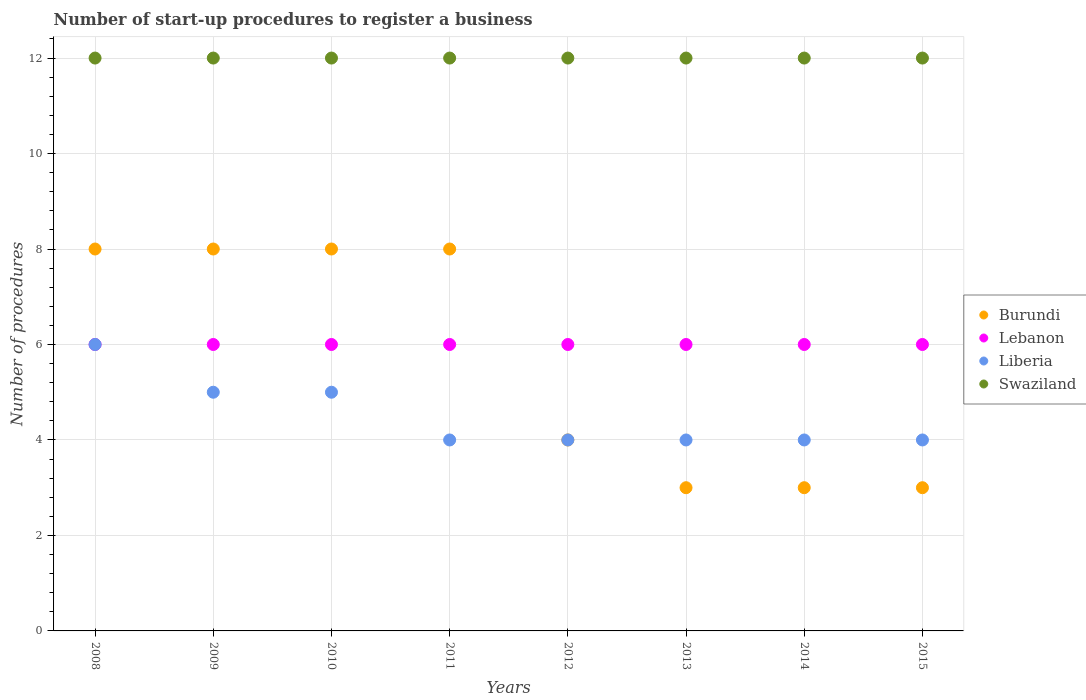What is the number of procedures required to register a business in Liberia in 2014?
Give a very brief answer. 4. Across all years, what is the maximum number of procedures required to register a business in Burundi?
Provide a succinct answer. 8. In which year was the number of procedures required to register a business in Lebanon minimum?
Make the answer very short. 2008. What is the total number of procedures required to register a business in Burundi in the graph?
Provide a short and direct response. 45. What is the difference between the number of procedures required to register a business in Lebanon in 2008 and that in 2009?
Provide a succinct answer. 0. What is the average number of procedures required to register a business in Lebanon per year?
Give a very brief answer. 6. In the year 2013, what is the difference between the number of procedures required to register a business in Liberia and number of procedures required to register a business in Burundi?
Your response must be concise. 1. What is the ratio of the number of procedures required to register a business in Liberia in 2009 to that in 2014?
Provide a short and direct response. 1.25. Is the number of procedures required to register a business in Burundi in 2011 less than that in 2014?
Your answer should be compact. No. Is the difference between the number of procedures required to register a business in Liberia in 2009 and 2011 greater than the difference between the number of procedures required to register a business in Burundi in 2009 and 2011?
Offer a very short reply. Yes. What is the difference between the highest and the lowest number of procedures required to register a business in Burundi?
Give a very brief answer. 5. Is the sum of the number of procedures required to register a business in Swaziland in 2011 and 2015 greater than the maximum number of procedures required to register a business in Burundi across all years?
Provide a short and direct response. Yes. Is it the case that in every year, the sum of the number of procedures required to register a business in Swaziland and number of procedures required to register a business in Burundi  is greater than the number of procedures required to register a business in Liberia?
Offer a very short reply. Yes. Does the number of procedures required to register a business in Burundi monotonically increase over the years?
Offer a very short reply. No. Is the number of procedures required to register a business in Liberia strictly greater than the number of procedures required to register a business in Swaziland over the years?
Provide a succinct answer. No. Is the number of procedures required to register a business in Burundi strictly less than the number of procedures required to register a business in Swaziland over the years?
Offer a very short reply. Yes. How many dotlines are there?
Keep it short and to the point. 4. How many years are there in the graph?
Your response must be concise. 8. What is the difference between two consecutive major ticks on the Y-axis?
Keep it short and to the point. 2. Does the graph contain any zero values?
Offer a very short reply. No. Does the graph contain grids?
Offer a very short reply. Yes. Where does the legend appear in the graph?
Offer a very short reply. Center right. How are the legend labels stacked?
Keep it short and to the point. Vertical. What is the title of the graph?
Your answer should be very brief. Number of start-up procedures to register a business. What is the label or title of the X-axis?
Give a very brief answer. Years. What is the label or title of the Y-axis?
Make the answer very short. Number of procedures. What is the Number of procedures of Burundi in 2008?
Offer a very short reply. 8. What is the Number of procedures of Swaziland in 2008?
Keep it short and to the point. 12. What is the Number of procedures in Burundi in 2009?
Offer a very short reply. 8. What is the Number of procedures of Lebanon in 2009?
Provide a succinct answer. 6. What is the Number of procedures in Liberia in 2009?
Your answer should be very brief. 5. What is the Number of procedures in Burundi in 2010?
Your answer should be very brief. 8. What is the Number of procedures of Liberia in 2010?
Give a very brief answer. 5. What is the Number of procedures in Burundi in 2011?
Offer a terse response. 8. What is the Number of procedures of Lebanon in 2011?
Keep it short and to the point. 6. What is the Number of procedures of Swaziland in 2011?
Your response must be concise. 12. What is the Number of procedures of Burundi in 2012?
Provide a succinct answer. 4. What is the Number of procedures of Burundi in 2013?
Ensure brevity in your answer.  3. What is the Number of procedures of Swaziland in 2013?
Keep it short and to the point. 12. What is the Number of procedures in Liberia in 2014?
Offer a terse response. 4. What is the Number of procedures of Swaziland in 2014?
Provide a short and direct response. 12. What is the Number of procedures of Burundi in 2015?
Keep it short and to the point. 3. What is the Number of procedures of Liberia in 2015?
Make the answer very short. 4. What is the Number of procedures in Swaziland in 2015?
Your answer should be very brief. 12. Across all years, what is the maximum Number of procedures in Burundi?
Offer a very short reply. 8. Across all years, what is the maximum Number of procedures of Liberia?
Provide a succinct answer. 6. Across all years, what is the minimum Number of procedures of Burundi?
Provide a succinct answer. 3. Across all years, what is the minimum Number of procedures of Lebanon?
Your response must be concise. 6. Across all years, what is the minimum Number of procedures in Liberia?
Keep it short and to the point. 4. What is the total Number of procedures in Burundi in the graph?
Provide a short and direct response. 45. What is the total Number of procedures of Swaziland in the graph?
Your response must be concise. 96. What is the difference between the Number of procedures of Burundi in 2008 and that in 2009?
Offer a very short reply. 0. What is the difference between the Number of procedures of Liberia in 2008 and that in 2009?
Provide a succinct answer. 1. What is the difference between the Number of procedures in Swaziland in 2008 and that in 2009?
Make the answer very short. 0. What is the difference between the Number of procedures of Swaziland in 2008 and that in 2010?
Make the answer very short. 0. What is the difference between the Number of procedures in Burundi in 2008 and that in 2011?
Offer a terse response. 0. What is the difference between the Number of procedures in Lebanon in 2008 and that in 2011?
Give a very brief answer. 0. What is the difference between the Number of procedures in Burundi in 2008 and that in 2012?
Give a very brief answer. 4. What is the difference between the Number of procedures in Swaziland in 2008 and that in 2012?
Ensure brevity in your answer.  0. What is the difference between the Number of procedures of Liberia in 2008 and that in 2013?
Ensure brevity in your answer.  2. What is the difference between the Number of procedures of Burundi in 2008 and that in 2014?
Your answer should be compact. 5. What is the difference between the Number of procedures in Lebanon in 2008 and that in 2014?
Offer a terse response. 0. What is the difference between the Number of procedures in Liberia in 2008 and that in 2014?
Provide a short and direct response. 2. What is the difference between the Number of procedures of Lebanon in 2009 and that in 2010?
Make the answer very short. 0. What is the difference between the Number of procedures of Liberia in 2009 and that in 2010?
Provide a succinct answer. 0. What is the difference between the Number of procedures in Lebanon in 2009 and that in 2011?
Ensure brevity in your answer.  0. What is the difference between the Number of procedures of Swaziland in 2009 and that in 2011?
Your answer should be compact. 0. What is the difference between the Number of procedures of Burundi in 2009 and that in 2012?
Offer a very short reply. 4. What is the difference between the Number of procedures in Lebanon in 2009 and that in 2012?
Offer a very short reply. 0. What is the difference between the Number of procedures of Liberia in 2009 and that in 2012?
Provide a succinct answer. 1. What is the difference between the Number of procedures of Swaziland in 2009 and that in 2012?
Give a very brief answer. 0. What is the difference between the Number of procedures in Liberia in 2009 and that in 2013?
Offer a very short reply. 1. What is the difference between the Number of procedures of Lebanon in 2009 and that in 2015?
Offer a terse response. 0. What is the difference between the Number of procedures of Liberia in 2009 and that in 2015?
Give a very brief answer. 1. What is the difference between the Number of procedures in Swaziland in 2009 and that in 2015?
Make the answer very short. 0. What is the difference between the Number of procedures in Liberia in 2010 and that in 2011?
Your answer should be very brief. 1. What is the difference between the Number of procedures of Burundi in 2010 and that in 2012?
Keep it short and to the point. 4. What is the difference between the Number of procedures in Liberia in 2010 and that in 2012?
Make the answer very short. 1. What is the difference between the Number of procedures in Swaziland in 2010 and that in 2012?
Ensure brevity in your answer.  0. What is the difference between the Number of procedures of Lebanon in 2010 and that in 2013?
Offer a very short reply. 0. What is the difference between the Number of procedures in Liberia in 2010 and that in 2013?
Your response must be concise. 1. What is the difference between the Number of procedures in Burundi in 2010 and that in 2014?
Ensure brevity in your answer.  5. What is the difference between the Number of procedures in Lebanon in 2010 and that in 2014?
Offer a terse response. 0. What is the difference between the Number of procedures in Lebanon in 2010 and that in 2015?
Provide a succinct answer. 0. What is the difference between the Number of procedures in Swaziland in 2010 and that in 2015?
Make the answer very short. 0. What is the difference between the Number of procedures in Burundi in 2011 and that in 2012?
Your response must be concise. 4. What is the difference between the Number of procedures in Lebanon in 2011 and that in 2013?
Provide a succinct answer. 0. What is the difference between the Number of procedures in Liberia in 2011 and that in 2013?
Provide a short and direct response. 0. What is the difference between the Number of procedures in Burundi in 2011 and that in 2014?
Make the answer very short. 5. What is the difference between the Number of procedures in Lebanon in 2011 and that in 2015?
Provide a short and direct response. 0. What is the difference between the Number of procedures of Swaziland in 2011 and that in 2015?
Your answer should be very brief. 0. What is the difference between the Number of procedures of Burundi in 2012 and that in 2013?
Provide a succinct answer. 1. What is the difference between the Number of procedures of Swaziland in 2012 and that in 2013?
Offer a very short reply. 0. What is the difference between the Number of procedures in Lebanon in 2012 and that in 2014?
Make the answer very short. 0. What is the difference between the Number of procedures of Burundi in 2012 and that in 2015?
Provide a succinct answer. 1. What is the difference between the Number of procedures of Lebanon in 2012 and that in 2015?
Provide a short and direct response. 0. What is the difference between the Number of procedures of Swaziland in 2012 and that in 2015?
Your answer should be very brief. 0. What is the difference between the Number of procedures of Liberia in 2013 and that in 2014?
Provide a short and direct response. 0. What is the difference between the Number of procedures of Swaziland in 2013 and that in 2014?
Provide a succinct answer. 0. What is the difference between the Number of procedures in Burundi in 2013 and that in 2015?
Keep it short and to the point. 0. What is the difference between the Number of procedures of Lebanon in 2013 and that in 2015?
Your answer should be very brief. 0. What is the difference between the Number of procedures of Swaziland in 2013 and that in 2015?
Provide a succinct answer. 0. What is the difference between the Number of procedures in Burundi in 2014 and that in 2015?
Offer a very short reply. 0. What is the difference between the Number of procedures in Lebanon in 2014 and that in 2015?
Ensure brevity in your answer.  0. What is the difference between the Number of procedures in Burundi in 2008 and the Number of procedures in Lebanon in 2010?
Your answer should be compact. 2. What is the difference between the Number of procedures in Burundi in 2008 and the Number of procedures in Liberia in 2010?
Provide a short and direct response. 3. What is the difference between the Number of procedures in Burundi in 2008 and the Number of procedures in Swaziland in 2010?
Give a very brief answer. -4. What is the difference between the Number of procedures in Lebanon in 2008 and the Number of procedures in Liberia in 2010?
Offer a very short reply. 1. What is the difference between the Number of procedures in Burundi in 2008 and the Number of procedures in Lebanon in 2011?
Offer a terse response. 2. What is the difference between the Number of procedures of Burundi in 2008 and the Number of procedures of Liberia in 2011?
Provide a succinct answer. 4. What is the difference between the Number of procedures in Lebanon in 2008 and the Number of procedures in Liberia in 2011?
Provide a succinct answer. 2. What is the difference between the Number of procedures of Liberia in 2008 and the Number of procedures of Swaziland in 2011?
Keep it short and to the point. -6. What is the difference between the Number of procedures in Burundi in 2008 and the Number of procedures in Liberia in 2012?
Give a very brief answer. 4. What is the difference between the Number of procedures of Lebanon in 2008 and the Number of procedures of Swaziland in 2012?
Your answer should be compact. -6. What is the difference between the Number of procedures of Liberia in 2008 and the Number of procedures of Swaziland in 2012?
Give a very brief answer. -6. What is the difference between the Number of procedures in Burundi in 2008 and the Number of procedures in Lebanon in 2013?
Your response must be concise. 2. What is the difference between the Number of procedures in Lebanon in 2008 and the Number of procedures in Liberia in 2013?
Give a very brief answer. 2. What is the difference between the Number of procedures in Burundi in 2008 and the Number of procedures in Liberia in 2014?
Keep it short and to the point. 4. What is the difference between the Number of procedures in Lebanon in 2008 and the Number of procedures in Swaziland in 2014?
Offer a terse response. -6. What is the difference between the Number of procedures of Burundi in 2008 and the Number of procedures of Swaziland in 2015?
Your answer should be very brief. -4. What is the difference between the Number of procedures of Lebanon in 2008 and the Number of procedures of Liberia in 2015?
Your answer should be compact. 2. What is the difference between the Number of procedures in Lebanon in 2008 and the Number of procedures in Swaziland in 2015?
Provide a succinct answer. -6. What is the difference between the Number of procedures in Burundi in 2009 and the Number of procedures in Lebanon in 2010?
Make the answer very short. 2. What is the difference between the Number of procedures in Lebanon in 2009 and the Number of procedures in Swaziland in 2010?
Keep it short and to the point. -6. What is the difference between the Number of procedures of Burundi in 2009 and the Number of procedures of Lebanon in 2011?
Your answer should be compact. 2. What is the difference between the Number of procedures of Burundi in 2009 and the Number of procedures of Liberia in 2011?
Your answer should be compact. 4. What is the difference between the Number of procedures in Lebanon in 2009 and the Number of procedures in Liberia in 2011?
Ensure brevity in your answer.  2. What is the difference between the Number of procedures in Liberia in 2009 and the Number of procedures in Swaziland in 2011?
Ensure brevity in your answer.  -7. What is the difference between the Number of procedures of Burundi in 2009 and the Number of procedures of Lebanon in 2012?
Your answer should be compact. 2. What is the difference between the Number of procedures of Burundi in 2009 and the Number of procedures of Liberia in 2012?
Your answer should be very brief. 4. What is the difference between the Number of procedures of Burundi in 2009 and the Number of procedures of Swaziland in 2012?
Provide a short and direct response. -4. What is the difference between the Number of procedures of Lebanon in 2009 and the Number of procedures of Liberia in 2012?
Make the answer very short. 2. What is the difference between the Number of procedures in Liberia in 2009 and the Number of procedures in Swaziland in 2012?
Ensure brevity in your answer.  -7. What is the difference between the Number of procedures in Lebanon in 2009 and the Number of procedures in Swaziland in 2013?
Your answer should be very brief. -6. What is the difference between the Number of procedures of Burundi in 2009 and the Number of procedures of Liberia in 2014?
Provide a succinct answer. 4. What is the difference between the Number of procedures in Lebanon in 2009 and the Number of procedures in Liberia in 2014?
Ensure brevity in your answer.  2. What is the difference between the Number of procedures of Lebanon in 2009 and the Number of procedures of Swaziland in 2014?
Offer a terse response. -6. What is the difference between the Number of procedures in Burundi in 2009 and the Number of procedures in Liberia in 2015?
Your answer should be compact. 4. What is the difference between the Number of procedures of Lebanon in 2009 and the Number of procedures of Liberia in 2015?
Keep it short and to the point. 2. What is the difference between the Number of procedures of Burundi in 2010 and the Number of procedures of Liberia in 2011?
Your answer should be very brief. 4. What is the difference between the Number of procedures of Burundi in 2010 and the Number of procedures of Swaziland in 2011?
Provide a succinct answer. -4. What is the difference between the Number of procedures of Lebanon in 2010 and the Number of procedures of Swaziland in 2011?
Your answer should be very brief. -6. What is the difference between the Number of procedures in Burundi in 2010 and the Number of procedures in Liberia in 2012?
Ensure brevity in your answer.  4. What is the difference between the Number of procedures in Burundi in 2010 and the Number of procedures in Swaziland in 2012?
Your answer should be compact. -4. What is the difference between the Number of procedures in Lebanon in 2010 and the Number of procedures in Liberia in 2012?
Make the answer very short. 2. What is the difference between the Number of procedures of Lebanon in 2010 and the Number of procedures of Swaziland in 2012?
Offer a very short reply. -6. What is the difference between the Number of procedures in Burundi in 2010 and the Number of procedures in Lebanon in 2013?
Your answer should be very brief. 2. What is the difference between the Number of procedures of Burundi in 2010 and the Number of procedures of Liberia in 2013?
Provide a short and direct response. 4. What is the difference between the Number of procedures of Lebanon in 2010 and the Number of procedures of Swaziland in 2013?
Offer a terse response. -6. What is the difference between the Number of procedures of Burundi in 2010 and the Number of procedures of Liberia in 2014?
Provide a short and direct response. 4. What is the difference between the Number of procedures in Burundi in 2010 and the Number of procedures in Liberia in 2015?
Your answer should be compact. 4. What is the difference between the Number of procedures of Lebanon in 2010 and the Number of procedures of Liberia in 2015?
Give a very brief answer. 2. What is the difference between the Number of procedures of Lebanon in 2010 and the Number of procedures of Swaziland in 2015?
Your response must be concise. -6. What is the difference between the Number of procedures in Liberia in 2010 and the Number of procedures in Swaziland in 2015?
Offer a terse response. -7. What is the difference between the Number of procedures in Burundi in 2011 and the Number of procedures in Liberia in 2012?
Provide a short and direct response. 4. What is the difference between the Number of procedures in Lebanon in 2011 and the Number of procedures in Liberia in 2012?
Ensure brevity in your answer.  2. What is the difference between the Number of procedures of Burundi in 2011 and the Number of procedures of Lebanon in 2013?
Offer a terse response. 2. What is the difference between the Number of procedures in Burundi in 2011 and the Number of procedures in Swaziland in 2013?
Your answer should be very brief. -4. What is the difference between the Number of procedures in Lebanon in 2011 and the Number of procedures in Liberia in 2013?
Provide a short and direct response. 2. What is the difference between the Number of procedures in Liberia in 2011 and the Number of procedures in Swaziland in 2013?
Ensure brevity in your answer.  -8. What is the difference between the Number of procedures of Burundi in 2011 and the Number of procedures of Lebanon in 2014?
Offer a terse response. 2. What is the difference between the Number of procedures in Burundi in 2011 and the Number of procedures in Liberia in 2014?
Give a very brief answer. 4. What is the difference between the Number of procedures of Liberia in 2011 and the Number of procedures of Swaziland in 2014?
Provide a succinct answer. -8. What is the difference between the Number of procedures in Burundi in 2011 and the Number of procedures in Liberia in 2015?
Your response must be concise. 4. What is the difference between the Number of procedures of Lebanon in 2011 and the Number of procedures of Swaziland in 2015?
Give a very brief answer. -6. What is the difference between the Number of procedures in Burundi in 2012 and the Number of procedures in Lebanon in 2013?
Your response must be concise. -2. What is the difference between the Number of procedures in Burundi in 2012 and the Number of procedures in Swaziland in 2013?
Offer a terse response. -8. What is the difference between the Number of procedures of Lebanon in 2012 and the Number of procedures of Liberia in 2013?
Provide a short and direct response. 2. What is the difference between the Number of procedures in Lebanon in 2012 and the Number of procedures in Swaziland in 2013?
Provide a succinct answer. -6. What is the difference between the Number of procedures in Liberia in 2012 and the Number of procedures in Swaziland in 2013?
Provide a short and direct response. -8. What is the difference between the Number of procedures in Burundi in 2012 and the Number of procedures in Swaziland in 2014?
Give a very brief answer. -8. What is the difference between the Number of procedures in Lebanon in 2012 and the Number of procedures in Liberia in 2014?
Keep it short and to the point. 2. What is the difference between the Number of procedures in Lebanon in 2012 and the Number of procedures in Swaziland in 2014?
Your response must be concise. -6. What is the difference between the Number of procedures of Liberia in 2012 and the Number of procedures of Swaziland in 2014?
Your answer should be very brief. -8. What is the difference between the Number of procedures of Liberia in 2012 and the Number of procedures of Swaziland in 2015?
Your answer should be very brief. -8. What is the difference between the Number of procedures of Burundi in 2013 and the Number of procedures of Lebanon in 2014?
Ensure brevity in your answer.  -3. What is the difference between the Number of procedures of Lebanon in 2013 and the Number of procedures of Liberia in 2014?
Keep it short and to the point. 2. What is the difference between the Number of procedures of Lebanon in 2013 and the Number of procedures of Swaziland in 2014?
Provide a succinct answer. -6. What is the difference between the Number of procedures in Liberia in 2013 and the Number of procedures in Swaziland in 2014?
Your answer should be very brief. -8. What is the difference between the Number of procedures in Burundi in 2013 and the Number of procedures in Liberia in 2015?
Offer a terse response. -1. What is the difference between the Number of procedures in Burundi in 2013 and the Number of procedures in Swaziland in 2015?
Give a very brief answer. -9. What is the difference between the Number of procedures of Lebanon in 2013 and the Number of procedures of Liberia in 2015?
Give a very brief answer. 2. What is the difference between the Number of procedures of Burundi in 2014 and the Number of procedures of Liberia in 2015?
Give a very brief answer. -1. What is the difference between the Number of procedures in Lebanon in 2014 and the Number of procedures in Liberia in 2015?
Give a very brief answer. 2. What is the difference between the Number of procedures in Liberia in 2014 and the Number of procedures in Swaziland in 2015?
Your response must be concise. -8. What is the average Number of procedures in Burundi per year?
Provide a succinct answer. 5.62. What is the average Number of procedures in Lebanon per year?
Ensure brevity in your answer.  6. What is the average Number of procedures of Liberia per year?
Your response must be concise. 4.5. In the year 2008, what is the difference between the Number of procedures in Burundi and Number of procedures in Liberia?
Provide a short and direct response. 2. In the year 2008, what is the difference between the Number of procedures of Burundi and Number of procedures of Swaziland?
Ensure brevity in your answer.  -4. In the year 2009, what is the difference between the Number of procedures of Burundi and Number of procedures of Lebanon?
Offer a terse response. 2. In the year 2009, what is the difference between the Number of procedures of Burundi and Number of procedures of Liberia?
Offer a very short reply. 3. In the year 2009, what is the difference between the Number of procedures of Liberia and Number of procedures of Swaziland?
Your answer should be very brief. -7. In the year 2010, what is the difference between the Number of procedures of Burundi and Number of procedures of Lebanon?
Keep it short and to the point. 2. In the year 2010, what is the difference between the Number of procedures of Burundi and Number of procedures of Liberia?
Give a very brief answer. 3. In the year 2010, what is the difference between the Number of procedures in Lebanon and Number of procedures in Liberia?
Your answer should be very brief. 1. In the year 2010, what is the difference between the Number of procedures of Liberia and Number of procedures of Swaziland?
Your answer should be compact. -7. In the year 2011, what is the difference between the Number of procedures in Burundi and Number of procedures in Lebanon?
Keep it short and to the point. 2. In the year 2011, what is the difference between the Number of procedures in Burundi and Number of procedures in Liberia?
Your answer should be very brief. 4. In the year 2011, what is the difference between the Number of procedures of Burundi and Number of procedures of Swaziland?
Your response must be concise. -4. In the year 2011, what is the difference between the Number of procedures in Lebanon and Number of procedures in Liberia?
Your answer should be compact. 2. In the year 2011, what is the difference between the Number of procedures of Lebanon and Number of procedures of Swaziland?
Your answer should be very brief. -6. In the year 2011, what is the difference between the Number of procedures in Liberia and Number of procedures in Swaziland?
Give a very brief answer. -8. In the year 2012, what is the difference between the Number of procedures of Burundi and Number of procedures of Liberia?
Provide a succinct answer. 0. In the year 2012, what is the difference between the Number of procedures in Lebanon and Number of procedures in Liberia?
Keep it short and to the point. 2. In the year 2012, what is the difference between the Number of procedures of Lebanon and Number of procedures of Swaziland?
Ensure brevity in your answer.  -6. In the year 2012, what is the difference between the Number of procedures of Liberia and Number of procedures of Swaziland?
Your answer should be very brief. -8. In the year 2013, what is the difference between the Number of procedures in Burundi and Number of procedures in Swaziland?
Offer a very short reply. -9. In the year 2014, what is the difference between the Number of procedures of Burundi and Number of procedures of Liberia?
Provide a short and direct response. -1. In the year 2014, what is the difference between the Number of procedures of Burundi and Number of procedures of Swaziland?
Keep it short and to the point. -9. In the year 2014, what is the difference between the Number of procedures of Lebanon and Number of procedures of Liberia?
Your answer should be very brief. 2. In the year 2014, what is the difference between the Number of procedures of Liberia and Number of procedures of Swaziland?
Provide a short and direct response. -8. In the year 2015, what is the difference between the Number of procedures in Burundi and Number of procedures in Liberia?
Provide a succinct answer. -1. In the year 2015, what is the difference between the Number of procedures of Lebanon and Number of procedures of Liberia?
Keep it short and to the point. 2. What is the ratio of the Number of procedures of Burundi in 2008 to that in 2009?
Make the answer very short. 1. What is the ratio of the Number of procedures in Lebanon in 2008 to that in 2009?
Keep it short and to the point. 1. What is the ratio of the Number of procedures of Swaziland in 2008 to that in 2009?
Your answer should be very brief. 1. What is the ratio of the Number of procedures of Lebanon in 2008 to that in 2010?
Provide a short and direct response. 1. What is the ratio of the Number of procedures in Burundi in 2008 to that in 2011?
Provide a short and direct response. 1. What is the ratio of the Number of procedures in Lebanon in 2008 to that in 2011?
Offer a very short reply. 1. What is the ratio of the Number of procedures in Swaziland in 2008 to that in 2011?
Your answer should be compact. 1. What is the ratio of the Number of procedures of Burundi in 2008 to that in 2012?
Offer a terse response. 2. What is the ratio of the Number of procedures of Lebanon in 2008 to that in 2012?
Make the answer very short. 1. What is the ratio of the Number of procedures of Liberia in 2008 to that in 2012?
Offer a very short reply. 1.5. What is the ratio of the Number of procedures of Swaziland in 2008 to that in 2012?
Offer a very short reply. 1. What is the ratio of the Number of procedures of Burundi in 2008 to that in 2013?
Make the answer very short. 2.67. What is the ratio of the Number of procedures of Liberia in 2008 to that in 2013?
Your response must be concise. 1.5. What is the ratio of the Number of procedures of Burundi in 2008 to that in 2014?
Make the answer very short. 2.67. What is the ratio of the Number of procedures of Lebanon in 2008 to that in 2014?
Your answer should be compact. 1. What is the ratio of the Number of procedures of Liberia in 2008 to that in 2014?
Give a very brief answer. 1.5. What is the ratio of the Number of procedures in Burundi in 2008 to that in 2015?
Your answer should be compact. 2.67. What is the ratio of the Number of procedures of Lebanon in 2008 to that in 2015?
Offer a very short reply. 1. What is the ratio of the Number of procedures of Liberia in 2009 to that in 2010?
Keep it short and to the point. 1. What is the ratio of the Number of procedures of Swaziland in 2009 to that in 2011?
Your answer should be compact. 1. What is the ratio of the Number of procedures in Burundi in 2009 to that in 2012?
Keep it short and to the point. 2. What is the ratio of the Number of procedures of Lebanon in 2009 to that in 2012?
Give a very brief answer. 1. What is the ratio of the Number of procedures of Liberia in 2009 to that in 2012?
Your response must be concise. 1.25. What is the ratio of the Number of procedures in Burundi in 2009 to that in 2013?
Offer a terse response. 2.67. What is the ratio of the Number of procedures in Lebanon in 2009 to that in 2013?
Your answer should be very brief. 1. What is the ratio of the Number of procedures in Swaziland in 2009 to that in 2013?
Keep it short and to the point. 1. What is the ratio of the Number of procedures in Burundi in 2009 to that in 2014?
Keep it short and to the point. 2.67. What is the ratio of the Number of procedures of Burundi in 2009 to that in 2015?
Keep it short and to the point. 2.67. What is the ratio of the Number of procedures of Lebanon in 2009 to that in 2015?
Offer a terse response. 1. What is the ratio of the Number of procedures of Liberia in 2009 to that in 2015?
Keep it short and to the point. 1.25. What is the ratio of the Number of procedures of Lebanon in 2010 to that in 2012?
Keep it short and to the point. 1. What is the ratio of the Number of procedures in Swaziland in 2010 to that in 2012?
Give a very brief answer. 1. What is the ratio of the Number of procedures of Burundi in 2010 to that in 2013?
Keep it short and to the point. 2.67. What is the ratio of the Number of procedures in Liberia in 2010 to that in 2013?
Ensure brevity in your answer.  1.25. What is the ratio of the Number of procedures in Swaziland in 2010 to that in 2013?
Your answer should be very brief. 1. What is the ratio of the Number of procedures in Burundi in 2010 to that in 2014?
Make the answer very short. 2.67. What is the ratio of the Number of procedures of Liberia in 2010 to that in 2014?
Provide a short and direct response. 1.25. What is the ratio of the Number of procedures in Burundi in 2010 to that in 2015?
Provide a short and direct response. 2.67. What is the ratio of the Number of procedures of Burundi in 2011 to that in 2012?
Provide a short and direct response. 2. What is the ratio of the Number of procedures of Lebanon in 2011 to that in 2012?
Your answer should be compact. 1. What is the ratio of the Number of procedures in Liberia in 2011 to that in 2012?
Offer a very short reply. 1. What is the ratio of the Number of procedures of Swaziland in 2011 to that in 2012?
Make the answer very short. 1. What is the ratio of the Number of procedures in Burundi in 2011 to that in 2013?
Provide a succinct answer. 2.67. What is the ratio of the Number of procedures of Lebanon in 2011 to that in 2013?
Your answer should be compact. 1. What is the ratio of the Number of procedures of Liberia in 2011 to that in 2013?
Give a very brief answer. 1. What is the ratio of the Number of procedures in Burundi in 2011 to that in 2014?
Make the answer very short. 2.67. What is the ratio of the Number of procedures in Lebanon in 2011 to that in 2014?
Offer a very short reply. 1. What is the ratio of the Number of procedures in Liberia in 2011 to that in 2014?
Your answer should be compact. 1. What is the ratio of the Number of procedures in Swaziland in 2011 to that in 2014?
Your answer should be very brief. 1. What is the ratio of the Number of procedures in Burundi in 2011 to that in 2015?
Provide a short and direct response. 2.67. What is the ratio of the Number of procedures of Lebanon in 2011 to that in 2015?
Your answer should be compact. 1. What is the ratio of the Number of procedures of Liberia in 2011 to that in 2015?
Keep it short and to the point. 1. What is the ratio of the Number of procedures in Burundi in 2012 to that in 2013?
Offer a terse response. 1.33. What is the ratio of the Number of procedures in Lebanon in 2012 to that in 2013?
Ensure brevity in your answer.  1. What is the ratio of the Number of procedures of Swaziland in 2012 to that in 2013?
Offer a very short reply. 1. What is the ratio of the Number of procedures of Lebanon in 2012 to that in 2014?
Your answer should be compact. 1. What is the ratio of the Number of procedures of Swaziland in 2012 to that in 2014?
Ensure brevity in your answer.  1. What is the ratio of the Number of procedures in Lebanon in 2012 to that in 2015?
Keep it short and to the point. 1. What is the ratio of the Number of procedures in Liberia in 2012 to that in 2015?
Provide a short and direct response. 1. What is the ratio of the Number of procedures in Burundi in 2013 to that in 2014?
Ensure brevity in your answer.  1. What is the ratio of the Number of procedures of Lebanon in 2013 to that in 2014?
Provide a short and direct response. 1. What is the ratio of the Number of procedures in Swaziland in 2013 to that in 2014?
Make the answer very short. 1. What is the ratio of the Number of procedures in Lebanon in 2013 to that in 2015?
Offer a very short reply. 1. What is the ratio of the Number of procedures of Liberia in 2013 to that in 2015?
Keep it short and to the point. 1. What is the ratio of the Number of procedures of Swaziland in 2013 to that in 2015?
Keep it short and to the point. 1. What is the difference between the highest and the second highest Number of procedures in Liberia?
Offer a terse response. 1. What is the difference between the highest and the lowest Number of procedures of Lebanon?
Give a very brief answer. 0. 